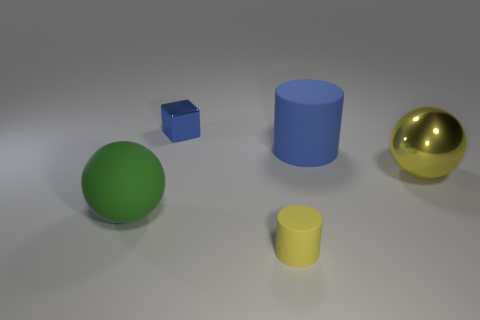Is there anything else that has the same shape as the blue shiny object?
Your answer should be very brief. No. How big is the yellow object left of the big rubber thing behind the large ball on the right side of the yellow rubber cylinder?
Give a very brief answer. Small. Is the number of rubber cylinders that are behind the green matte ball greater than the number of tiny gray metal cylinders?
Your response must be concise. Yes. Is there a big cyan sphere?
Your answer should be compact. No. How many matte balls are the same size as the blue metal thing?
Your response must be concise. 0. Is the number of shiny things in front of the large blue matte cylinder greater than the number of blue metal blocks in front of the yellow metallic thing?
Make the answer very short. Yes. There is a green object that is the same size as the blue rubber cylinder; what is it made of?
Your response must be concise. Rubber. What is the shape of the yellow metallic thing?
Your answer should be compact. Sphere. What number of blue things are large matte cylinders or cubes?
Provide a succinct answer. 2. There is another cylinder that is the same material as the yellow cylinder; what size is it?
Your response must be concise. Large. 